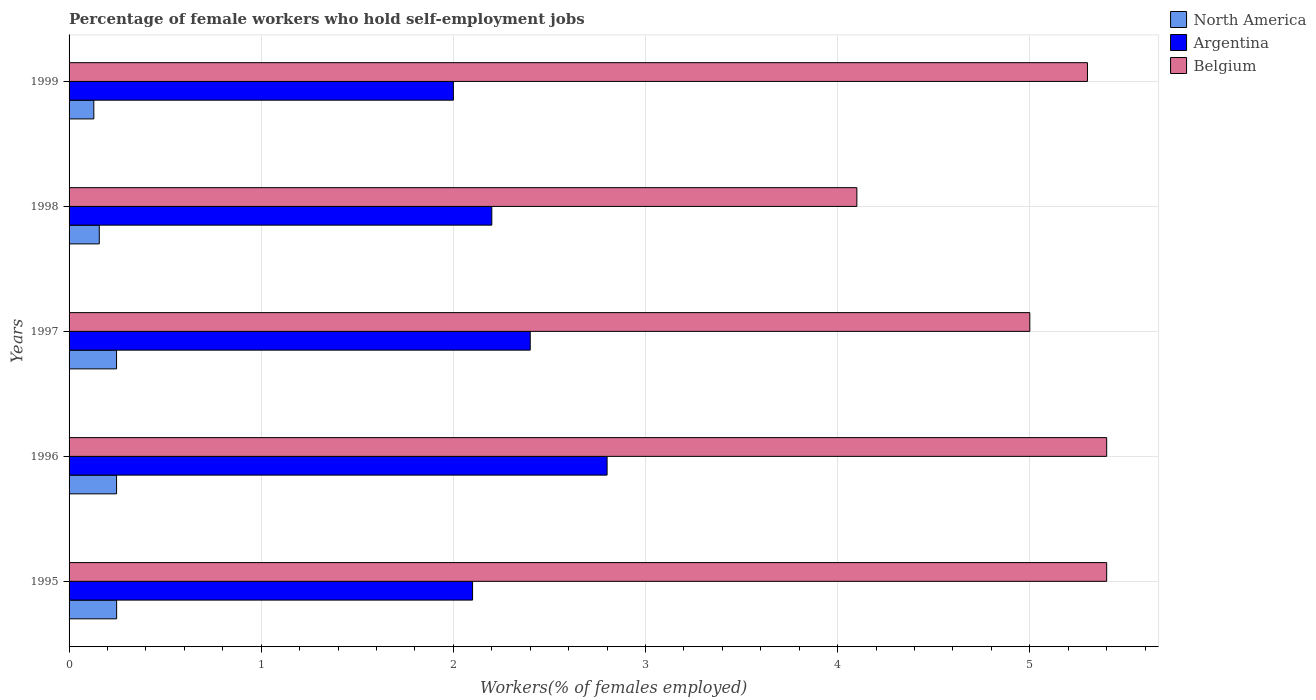How many different coloured bars are there?
Your answer should be compact. 3. Are the number of bars on each tick of the Y-axis equal?
Your answer should be very brief. Yes. How many bars are there on the 5th tick from the top?
Your answer should be very brief. 3. What is the label of the 2nd group of bars from the top?
Make the answer very short. 1998. What is the percentage of self-employed female workers in North America in 1996?
Your response must be concise. 0.25. Across all years, what is the maximum percentage of self-employed female workers in Argentina?
Give a very brief answer. 2.8. Across all years, what is the minimum percentage of self-employed female workers in Argentina?
Your response must be concise. 2. What is the total percentage of self-employed female workers in Argentina in the graph?
Make the answer very short. 11.5. What is the difference between the percentage of self-employed female workers in North America in 1995 and that in 1997?
Ensure brevity in your answer.  0. What is the difference between the percentage of self-employed female workers in Argentina in 1996 and the percentage of self-employed female workers in Belgium in 1995?
Offer a terse response. -2.6. In the year 1995, what is the difference between the percentage of self-employed female workers in North America and percentage of self-employed female workers in Argentina?
Provide a succinct answer. -1.85. In how many years, is the percentage of self-employed female workers in North America greater than 4 %?
Your answer should be very brief. 0. What is the ratio of the percentage of self-employed female workers in Belgium in 1996 to that in 1998?
Give a very brief answer. 1.32. Is the percentage of self-employed female workers in Belgium in 1995 less than that in 1996?
Your answer should be compact. No. What is the difference between the highest and the second highest percentage of self-employed female workers in Argentina?
Your response must be concise. 0.4. What is the difference between the highest and the lowest percentage of self-employed female workers in North America?
Ensure brevity in your answer.  0.12. What does the 3rd bar from the bottom in 1998 represents?
Give a very brief answer. Belgium. How many bars are there?
Ensure brevity in your answer.  15. Are all the bars in the graph horizontal?
Your response must be concise. Yes. How many years are there in the graph?
Offer a terse response. 5. Are the values on the major ticks of X-axis written in scientific E-notation?
Provide a succinct answer. No. Does the graph contain grids?
Offer a very short reply. Yes. How many legend labels are there?
Provide a short and direct response. 3. How are the legend labels stacked?
Provide a short and direct response. Vertical. What is the title of the graph?
Offer a very short reply. Percentage of female workers who hold self-employment jobs. Does "Kuwait" appear as one of the legend labels in the graph?
Make the answer very short. No. What is the label or title of the X-axis?
Keep it short and to the point. Workers(% of females employed). What is the label or title of the Y-axis?
Keep it short and to the point. Years. What is the Workers(% of females employed) of North America in 1995?
Provide a succinct answer. 0.25. What is the Workers(% of females employed) in Argentina in 1995?
Give a very brief answer. 2.1. What is the Workers(% of females employed) in Belgium in 1995?
Offer a terse response. 5.4. What is the Workers(% of females employed) in North America in 1996?
Provide a short and direct response. 0.25. What is the Workers(% of females employed) in Argentina in 1996?
Your response must be concise. 2.8. What is the Workers(% of females employed) in Belgium in 1996?
Provide a short and direct response. 5.4. What is the Workers(% of females employed) of North America in 1997?
Your answer should be very brief. 0.25. What is the Workers(% of females employed) of Argentina in 1997?
Ensure brevity in your answer.  2.4. What is the Workers(% of females employed) of Belgium in 1997?
Offer a terse response. 5. What is the Workers(% of females employed) in North America in 1998?
Your response must be concise. 0.16. What is the Workers(% of females employed) in Argentina in 1998?
Provide a succinct answer. 2.2. What is the Workers(% of females employed) of Belgium in 1998?
Keep it short and to the point. 4.1. What is the Workers(% of females employed) of North America in 1999?
Offer a terse response. 0.13. What is the Workers(% of females employed) in Belgium in 1999?
Ensure brevity in your answer.  5.3. Across all years, what is the maximum Workers(% of females employed) in North America?
Give a very brief answer. 0.25. Across all years, what is the maximum Workers(% of females employed) in Argentina?
Your answer should be compact. 2.8. Across all years, what is the maximum Workers(% of females employed) in Belgium?
Your answer should be compact. 5.4. Across all years, what is the minimum Workers(% of females employed) of North America?
Ensure brevity in your answer.  0.13. Across all years, what is the minimum Workers(% of females employed) in Belgium?
Make the answer very short. 4.1. What is the total Workers(% of females employed) of North America in the graph?
Provide a short and direct response. 1.03. What is the total Workers(% of females employed) of Belgium in the graph?
Your response must be concise. 25.2. What is the difference between the Workers(% of females employed) in North America in 1995 and that in 1996?
Make the answer very short. 0. What is the difference between the Workers(% of females employed) in Belgium in 1995 and that in 1996?
Ensure brevity in your answer.  0. What is the difference between the Workers(% of females employed) of North America in 1995 and that in 1998?
Make the answer very short. 0.09. What is the difference between the Workers(% of females employed) in Argentina in 1995 and that in 1998?
Give a very brief answer. -0.1. What is the difference between the Workers(% of females employed) of Belgium in 1995 and that in 1998?
Provide a succinct answer. 1.3. What is the difference between the Workers(% of females employed) in North America in 1995 and that in 1999?
Give a very brief answer. 0.12. What is the difference between the Workers(% of females employed) in Belgium in 1995 and that in 1999?
Make the answer very short. 0.1. What is the difference between the Workers(% of females employed) of Argentina in 1996 and that in 1997?
Your answer should be compact. 0.4. What is the difference between the Workers(% of females employed) in Belgium in 1996 and that in 1997?
Your response must be concise. 0.4. What is the difference between the Workers(% of females employed) of North America in 1996 and that in 1998?
Give a very brief answer. 0.09. What is the difference between the Workers(% of females employed) in Argentina in 1996 and that in 1998?
Provide a succinct answer. 0.6. What is the difference between the Workers(% of females employed) of North America in 1996 and that in 1999?
Offer a terse response. 0.12. What is the difference between the Workers(% of females employed) of Argentina in 1996 and that in 1999?
Your answer should be very brief. 0.8. What is the difference between the Workers(% of females employed) in Belgium in 1996 and that in 1999?
Ensure brevity in your answer.  0.1. What is the difference between the Workers(% of females employed) of North America in 1997 and that in 1998?
Make the answer very short. 0.09. What is the difference between the Workers(% of females employed) of North America in 1997 and that in 1999?
Offer a terse response. 0.12. What is the difference between the Workers(% of females employed) of Belgium in 1997 and that in 1999?
Make the answer very short. -0.3. What is the difference between the Workers(% of females employed) of North America in 1998 and that in 1999?
Your answer should be compact. 0.03. What is the difference between the Workers(% of females employed) of Belgium in 1998 and that in 1999?
Give a very brief answer. -1.2. What is the difference between the Workers(% of females employed) of North America in 1995 and the Workers(% of females employed) of Argentina in 1996?
Make the answer very short. -2.55. What is the difference between the Workers(% of females employed) in North America in 1995 and the Workers(% of females employed) in Belgium in 1996?
Your answer should be compact. -5.15. What is the difference between the Workers(% of females employed) of Argentina in 1995 and the Workers(% of females employed) of Belgium in 1996?
Offer a very short reply. -3.3. What is the difference between the Workers(% of females employed) of North America in 1995 and the Workers(% of females employed) of Argentina in 1997?
Ensure brevity in your answer.  -2.15. What is the difference between the Workers(% of females employed) of North America in 1995 and the Workers(% of females employed) of Belgium in 1997?
Make the answer very short. -4.75. What is the difference between the Workers(% of females employed) of North America in 1995 and the Workers(% of females employed) of Argentina in 1998?
Ensure brevity in your answer.  -1.95. What is the difference between the Workers(% of females employed) of North America in 1995 and the Workers(% of females employed) of Belgium in 1998?
Your answer should be compact. -3.85. What is the difference between the Workers(% of females employed) of Argentina in 1995 and the Workers(% of females employed) of Belgium in 1998?
Offer a very short reply. -2. What is the difference between the Workers(% of females employed) in North America in 1995 and the Workers(% of females employed) in Argentina in 1999?
Offer a terse response. -1.75. What is the difference between the Workers(% of females employed) of North America in 1995 and the Workers(% of females employed) of Belgium in 1999?
Offer a very short reply. -5.05. What is the difference between the Workers(% of females employed) of Argentina in 1995 and the Workers(% of females employed) of Belgium in 1999?
Provide a short and direct response. -3.2. What is the difference between the Workers(% of females employed) of North America in 1996 and the Workers(% of females employed) of Argentina in 1997?
Your answer should be very brief. -2.15. What is the difference between the Workers(% of females employed) of North America in 1996 and the Workers(% of females employed) of Belgium in 1997?
Offer a terse response. -4.75. What is the difference between the Workers(% of females employed) of Argentina in 1996 and the Workers(% of females employed) of Belgium in 1997?
Your response must be concise. -2.2. What is the difference between the Workers(% of females employed) in North America in 1996 and the Workers(% of females employed) in Argentina in 1998?
Your answer should be very brief. -1.95. What is the difference between the Workers(% of females employed) of North America in 1996 and the Workers(% of females employed) of Belgium in 1998?
Your answer should be compact. -3.85. What is the difference between the Workers(% of females employed) of North America in 1996 and the Workers(% of females employed) of Argentina in 1999?
Ensure brevity in your answer.  -1.75. What is the difference between the Workers(% of females employed) in North America in 1996 and the Workers(% of females employed) in Belgium in 1999?
Make the answer very short. -5.05. What is the difference between the Workers(% of females employed) of Argentina in 1996 and the Workers(% of females employed) of Belgium in 1999?
Your response must be concise. -2.5. What is the difference between the Workers(% of females employed) of North America in 1997 and the Workers(% of females employed) of Argentina in 1998?
Ensure brevity in your answer.  -1.95. What is the difference between the Workers(% of females employed) in North America in 1997 and the Workers(% of females employed) in Belgium in 1998?
Offer a very short reply. -3.85. What is the difference between the Workers(% of females employed) in Argentina in 1997 and the Workers(% of females employed) in Belgium in 1998?
Give a very brief answer. -1.7. What is the difference between the Workers(% of females employed) of North America in 1997 and the Workers(% of females employed) of Argentina in 1999?
Your answer should be compact. -1.75. What is the difference between the Workers(% of females employed) of North America in 1997 and the Workers(% of females employed) of Belgium in 1999?
Provide a short and direct response. -5.05. What is the difference between the Workers(% of females employed) in North America in 1998 and the Workers(% of females employed) in Argentina in 1999?
Offer a terse response. -1.84. What is the difference between the Workers(% of females employed) of North America in 1998 and the Workers(% of females employed) of Belgium in 1999?
Keep it short and to the point. -5.14. What is the average Workers(% of females employed) in North America per year?
Offer a terse response. 0.21. What is the average Workers(% of females employed) in Argentina per year?
Give a very brief answer. 2.3. What is the average Workers(% of females employed) of Belgium per year?
Your response must be concise. 5.04. In the year 1995, what is the difference between the Workers(% of females employed) in North America and Workers(% of females employed) in Argentina?
Give a very brief answer. -1.85. In the year 1995, what is the difference between the Workers(% of females employed) of North America and Workers(% of females employed) of Belgium?
Your response must be concise. -5.15. In the year 1996, what is the difference between the Workers(% of females employed) in North America and Workers(% of females employed) in Argentina?
Provide a succinct answer. -2.55. In the year 1996, what is the difference between the Workers(% of females employed) of North America and Workers(% of females employed) of Belgium?
Provide a short and direct response. -5.15. In the year 1997, what is the difference between the Workers(% of females employed) of North America and Workers(% of females employed) of Argentina?
Your answer should be very brief. -2.15. In the year 1997, what is the difference between the Workers(% of females employed) in North America and Workers(% of females employed) in Belgium?
Ensure brevity in your answer.  -4.75. In the year 1998, what is the difference between the Workers(% of females employed) in North America and Workers(% of females employed) in Argentina?
Make the answer very short. -2.04. In the year 1998, what is the difference between the Workers(% of females employed) of North America and Workers(% of females employed) of Belgium?
Give a very brief answer. -3.94. In the year 1998, what is the difference between the Workers(% of females employed) in Argentina and Workers(% of females employed) in Belgium?
Keep it short and to the point. -1.9. In the year 1999, what is the difference between the Workers(% of females employed) in North America and Workers(% of females employed) in Argentina?
Your response must be concise. -1.87. In the year 1999, what is the difference between the Workers(% of females employed) in North America and Workers(% of females employed) in Belgium?
Provide a succinct answer. -5.17. What is the ratio of the Workers(% of females employed) in North America in 1995 to that in 1996?
Provide a succinct answer. 1. What is the ratio of the Workers(% of females employed) of Argentina in 1995 to that in 1996?
Keep it short and to the point. 0.75. What is the ratio of the Workers(% of females employed) of North America in 1995 to that in 1997?
Offer a terse response. 1. What is the ratio of the Workers(% of females employed) of Argentina in 1995 to that in 1997?
Provide a succinct answer. 0.88. What is the ratio of the Workers(% of females employed) in North America in 1995 to that in 1998?
Your answer should be very brief. 1.57. What is the ratio of the Workers(% of females employed) in Argentina in 1995 to that in 1998?
Offer a terse response. 0.95. What is the ratio of the Workers(% of females employed) in Belgium in 1995 to that in 1998?
Give a very brief answer. 1.32. What is the ratio of the Workers(% of females employed) in North America in 1995 to that in 1999?
Give a very brief answer. 1.92. What is the ratio of the Workers(% of females employed) in Argentina in 1995 to that in 1999?
Your response must be concise. 1.05. What is the ratio of the Workers(% of females employed) in Belgium in 1995 to that in 1999?
Ensure brevity in your answer.  1.02. What is the ratio of the Workers(% of females employed) of Argentina in 1996 to that in 1997?
Ensure brevity in your answer.  1.17. What is the ratio of the Workers(% of females employed) of Belgium in 1996 to that in 1997?
Your answer should be very brief. 1.08. What is the ratio of the Workers(% of females employed) in North America in 1996 to that in 1998?
Give a very brief answer. 1.57. What is the ratio of the Workers(% of females employed) in Argentina in 1996 to that in 1998?
Provide a succinct answer. 1.27. What is the ratio of the Workers(% of females employed) of Belgium in 1996 to that in 1998?
Make the answer very short. 1.32. What is the ratio of the Workers(% of females employed) of North America in 1996 to that in 1999?
Ensure brevity in your answer.  1.92. What is the ratio of the Workers(% of females employed) of Argentina in 1996 to that in 1999?
Your response must be concise. 1.4. What is the ratio of the Workers(% of females employed) of Belgium in 1996 to that in 1999?
Offer a terse response. 1.02. What is the ratio of the Workers(% of females employed) of North America in 1997 to that in 1998?
Ensure brevity in your answer.  1.57. What is the ratio of the Workers(% of females employed) in Belgium in 1997 to that in 1998?
Your response must be concise. 1.22. What is the ratio of the Workers(% of females employed) of North America in 1997 to that in 1999?
Your answer should be very brief. 1.92. What is the ratio of the Workers(% of females employed) in Belgium in 1997 to that in 1999?
Make the answer very short. 0.94. What is the ratio of the Workers(% of females employed) of North America in 1998 to that in 1999?
Provide a short and direct response. 1.22. What is the ratio of the Workers(% of females employed) in Argentina in 1998 to that in 1999?
Your response must be concise. 1.1. What is the ratio of the Workers(% of females employed) in Belgium in 1998 to that in 1999?
Your answer should be compact. 0.77. What is the difference between the highest and the second highest Workers(% of females employed) in North America?
Keep it short and to the point. 0. What is the difference between the highest and the second highest Workers(% of females employed) of Argentina?
Give a very brief answer. 0.4. What is the difference between the highest and the lowest Workers(% of females employed) of North America?
Make the answer very short. 0.12. What is the difference between the highest and the lowest Workers(% of females employed) in Argentina?
Offer a very short reply. 0.8. 